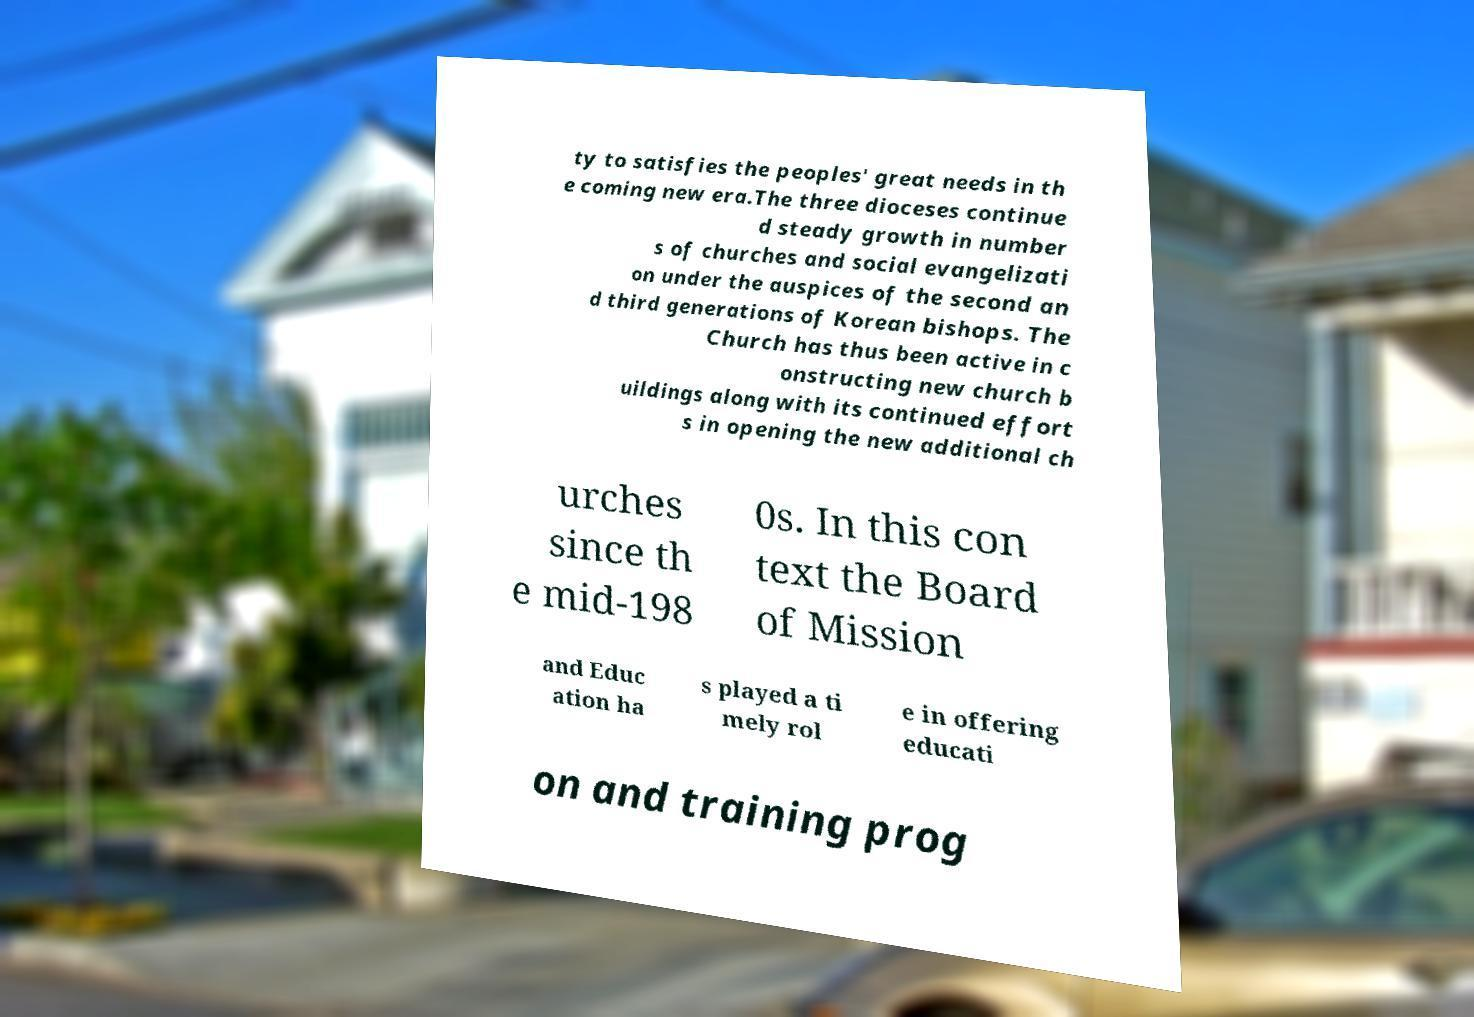Could you assist in decoding the text presented in this image and type it out clearly? ty to satisfies the peoples' great needs in th e coming new era.The three dioceses continue d steady growth in number s of churches and social evangelizati on under the auspices of the second an d third generations of Korean bishops. The Church has thus been active in c onstructing new church b uildings along with its continued effort s in opening the new additional ch urches since th e mid-198 0s. In this con text the Board of Mission and Educ ation ha s played a ti mely rol e in offering educati on and training prog 